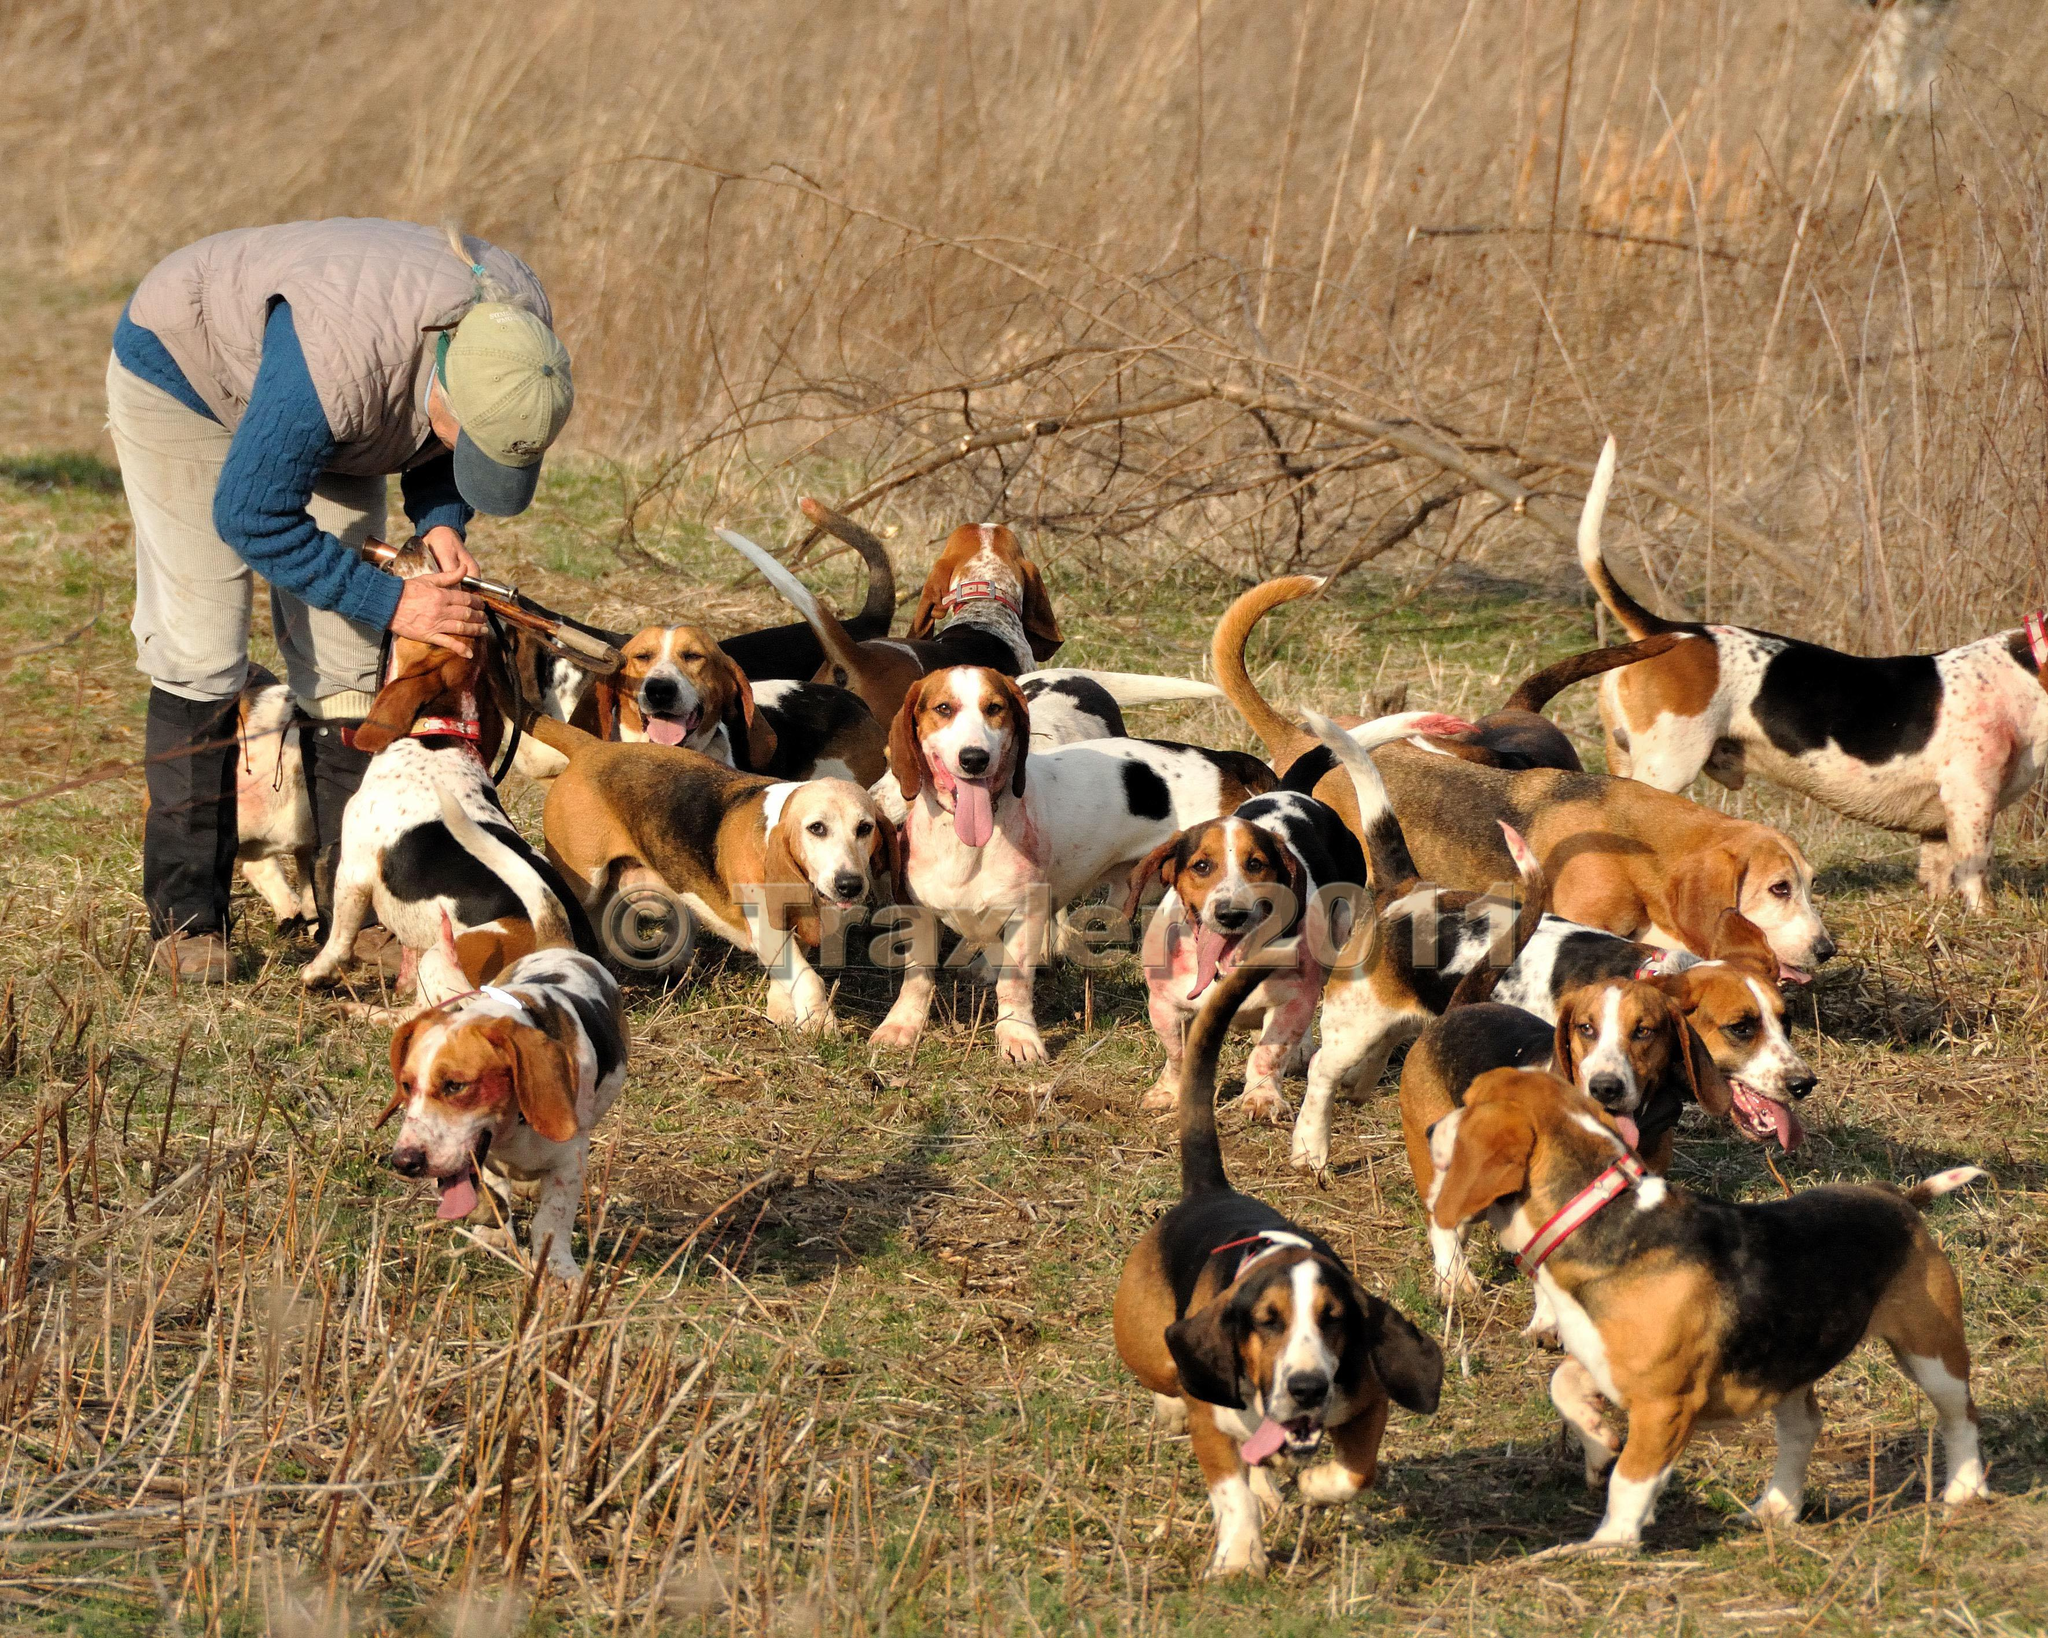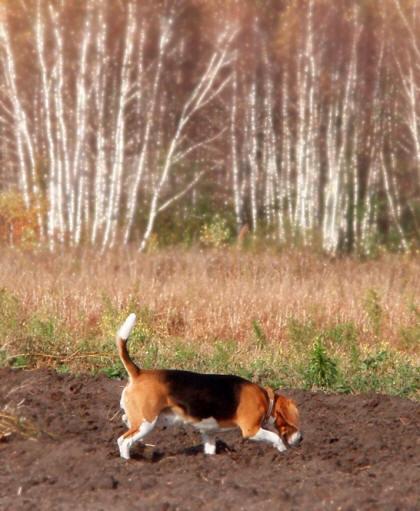The first image is the image on the left, the second image is the image on the right. Examine the images to the left and right. Is the description "In total, images contain no more than three beagles." accurate? Answer yes or no. No. 